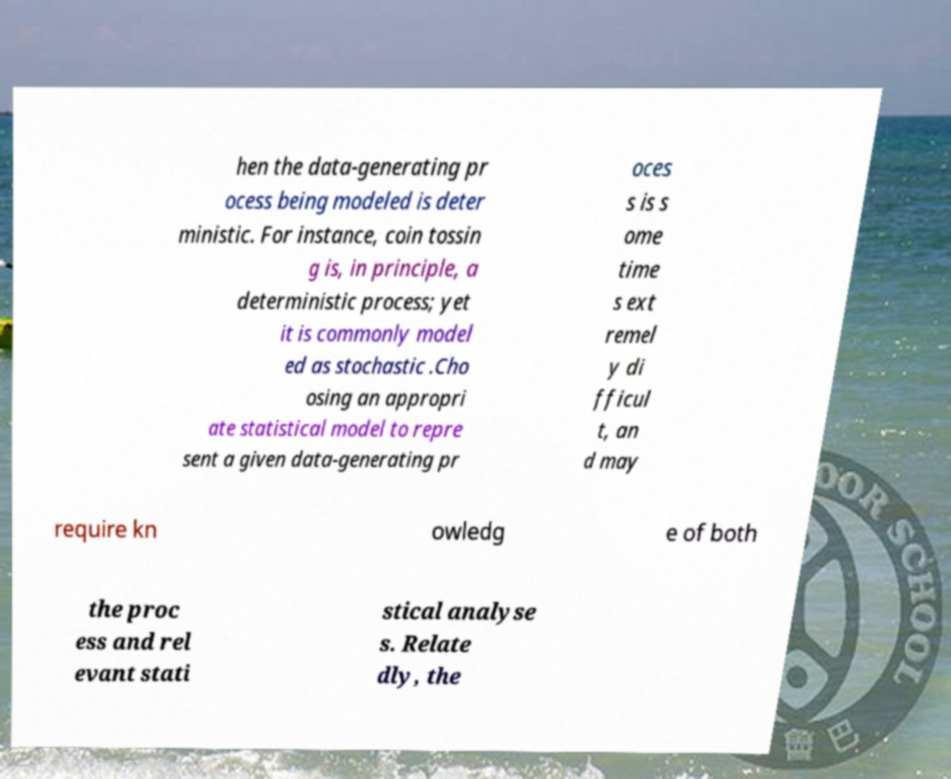Could you extract and type out the text from this image? hen the data-generating pr ocess being modeled is deter ministic. For instance, coin tossin g is, in principle, a deterministic process; yet it is commonly model ed as stochastic .Cho osing an appropri ate statistical model to repre sent a given data-generating pr oces s is s ome time s ext remel y di fficul t, an d may require kn owledg e of both the proc ess and rel evant stati stical analyse s. Relate dly, the 